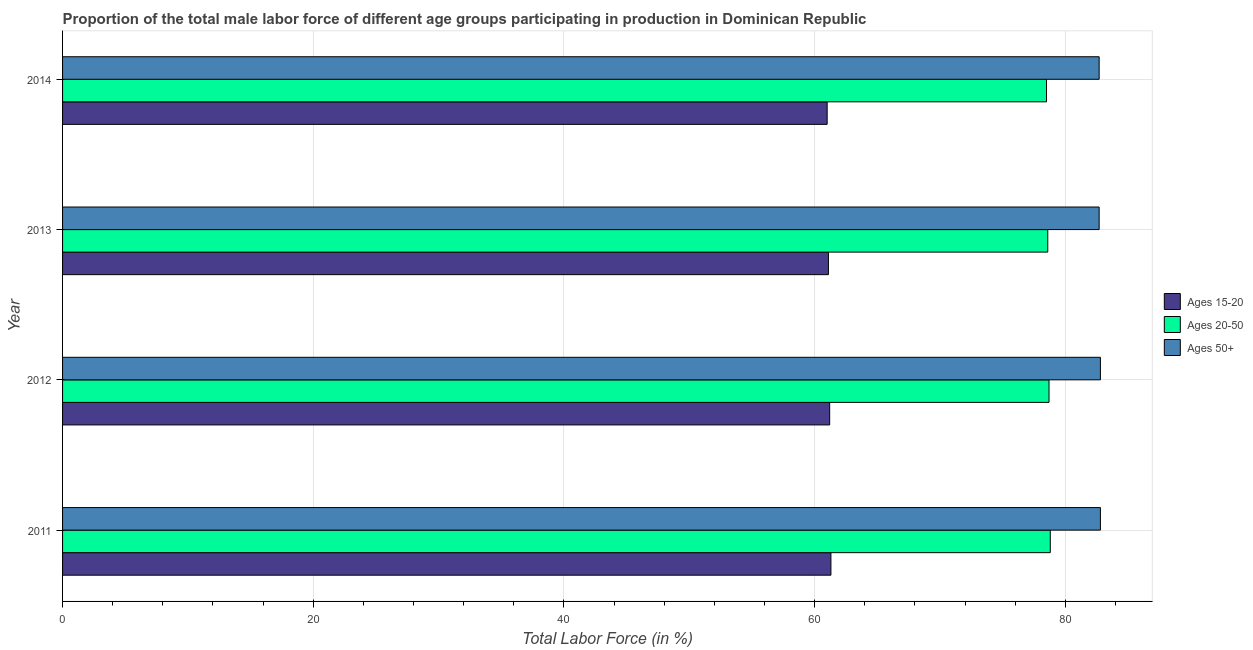How many different coloured bars are there?
Give a very brief answer. 3. What is the label of the 2nd group of bars from the top?
Your response must be concise. 2013. What is the percentage of male labor force within the age group 20-50 in 2011?
Your answer should be very brief. 78.8. Across all years, what is the maximum percentage of male labor force within the age group 15-20?
Provide a succinct answer. 61.3. Across all years, what is the minimum percentage of male labor force within the age group 20-50?
Your answer should be very brief. 78.5. In which year was the percentage of male labor force within the age group 15-20 maximum?
Keep it short and to the point. 2011. In which year was the percentage of male labor force within the age group 20-50 minimum?
Provide a short and direct response. 2014. What is the total percentage of male labor force within the age group 15-20 in the graph?
Offer a terse response. 244.6. What is the difference between the percentage of male labor force within the age group 15-20 in 2011 and that in 2012?
Offer a terse response. 0.1. What is the difference between the percentage of male labor force above age 50 in 2013 and the percentage of male labor force within the age group 15-20 in 2011?
Keep it short and to the point. 21.4. What is the average percentage of male labor force within the age group 15-20 per year?
Provide a succinct answer. 61.15. What is the ratio of the percentage of male labor force within the age group 15-20 in 2013 to that in 2014?
Keep it short and to the point. 1. Is the percentage of male labor force above age 50 in 2012 less than that in 2013?
Provide a succinct answer. No. Is the difference between the percentage of male labor force within the age group 15-20 in 2013 and 2014 greater than the difference between the percentage of male labor force above age 50 in 2013 and 2014?
Keep it short and to the point. Yes. What is the difference between the highest and the lowest percentage of male labor force within the age group 15-20?
Offer a very short reply. 0.3. What does the 2nd bar from the top in 2012 represents?
Your answer should be very brief. Ages 20-50. What does the 1st bar from the bottom in 2014 represents?
Offer a very short reply. Ages 15-20. Are all the bars in the graph horizontal?
Make the answer very short. Yes. How many years are there in the graph?
Your answer should be compact. 4. Does the graph contain any zero values?
Give a very brief answer. No. Where does the legend appear in the graph?
Ensure brevity in your answer.  Center right. How many legend labels are there?
Offer a very short reply. 3. How are the legend labels stacked?
Provide a succinct answer. Vertical. What is the title of the graph?
Offer a very short reply. Proportion of the total male labor force of different age groups participating in production in Dominican Republic. What is the label or title of the X-axis?
Provide a short and direct response. Total Labor Force (in %). What is the label or title of the Y-axis?
Provide a short and direct response. Year. What is the Total Labor Force (in %) of Ages 15-20 in 2011?
Your answer should be compact. 61.3. What is the Total Labor Force (in %) in Ages 20-50 in 2011?
Your response must be concise. 78.8. What is the Total Labor Force (in %) of Ages 50+ in 2011?
Give a very brief answer. 82.8. What is the Total Labor Force (in %) of Ages 15-20 in 2012?
Offer a terse response. 61.2. What is the Total Labor Force (in %) of Ages 20-50 in 2012?
Keep it short and to the point. 78.7. What is the Total Labor Force (in %) in Ages 50+ in 2012?
Provide a short and direct response. 82.8. What is the Total Labor Force (in %) in Ages 15-20 in 2013?
Keep it short and to the point. 61.1. What is the Total Labor Force (in %) of Ages 20-50 in 2013?
Make the answer very short. 78.6. What is the Total Labor Force (in %) of Ages 50+ in 2013?
Provide a succinct answer. 82.7. What is the Total Labor Force (in %) in Ages 15-20 in 2014?
Your answer should be very brief. 61. What is the Total Labor Force (in %) in Ages 20-50 in 2014?
Provide a succinct answer. 78.5. What is the Total Labor Force (in %) of Ages 50+ in 2014?
Your response must be concise. 82.7. Across all years, what is the maximum Total Labor Force (in %) of Ages 15-20?
Your answer should be compact. 61.3. Across all years, what is the maximum Total Labor Force (in %) of Ages 20-50?
Give a very brief answer. 78.8. Across all years, what is the maximum Total Labor Force (in %) of Ages 50+?
Keep it short and to the point. 82.8. Across all years, what is the minimum Total Labor Force (in %) in Ages 20-50?
Your answer should be very brief. 78.5. Across all years, what is the minimum Total Labor Force (in %) in Ages 50+?
Make the answer very short. 82.7. What is the total Total Labor Force (in %) in Ages 15-20 in the graph?
Provide a short and direct response. 244.6. What is the total Total Labor Force (in %) of Ages 20-50 in the graph?
Make the answer very short. 314.6. What is the total Total Labor Force (in %) of Ages 50+ in the graph?
Offer a very short reply. 331. What is the difference between the Total Labor Force (in %) in Ages 20-50 in 2011 and that in 2012?
Your response must be concise. 0.1. What is the difference between the Total Labor Force (in %) in Ages 50+ in 2011 and that in 2012?
Your answer should be very brief. 0. What is the difference between the Total Labor Force (in %) of Ages 15-20 in 2011 and that in 2013?
Provide a short and direct response. 0.2. What is the difference between the Total Labor Force (in %) in Ages 20-50 in 2011 and that in 2013?
Ensure brevity in your answer.  0.2. What is the difference between the Total Labor Force (in %) of Ages 20-50 in 2011 and that in 2014?
Give a very brief answer. 0.3. What is the difference between the Total Labor Force (in %) in Ages 50+ in 2011 and that in 2014?
Ensure brevity in your answer.  0.1. What is the difference between the Total Labor Force (in %) in Ages 15-20 in 2012 and that in 2013?
Give a very brief answer. 0.1. What is the difference between the Total Labor Force (in %) of Ages 20-50 in 2012 and that in 2013?
Keep it short and to the point. 0.1. What is the difference between the Total Labor Force (in %) of Ages 50+ in 2012 and that in 2014?
Provide a succinct answer. 0.1. What is the difference between the Total Labor Force (in %) in Ages 20-50 in 2013 and that in 2014?
Offer a very short reply. 0.1. What is the difference between the Total Labor Force (in %) of Ages 15-20 in 2011 and the Total Labor Force (in %) of Ages 20-50 in 2012?
Offer a terse response. -17.4. What is the difference between the Total Labor Force (in %) of Ages 15-20 in 2011 and the Total Labor Force (in %) of Ages 50+ in 2012?
Provide a short and direct response. -21.5. What is the difference between the Total Labor Force (in %) in Ages 20-50 in 2011 and the Total Labor Force (in %) in Ages 50+ in 2012?
Ensure brevity in your answer.  -4. What is the difference between the Total Labor Force (in %) in Ages 15-20 in 2011 and the Total Labor Force (in %) in Ages 20-50 in 2013?
Keep it short and to the point. -17.3. What is the difference between the Total Labor Force (in %) of Ages 15-20 in 2011 and the Total Labor Force (in %) of Ages 50+ in 2013?
Your answer should be very brief. -21.4. What is the difference between the Total Labor Force (in %) of Ages 20-50 in 2011 and the Total Labor Force (in %) of Ages 50+ in 2013?
Your answer should be very brief. -3.9. What is the difference between the Total Labor Force (in %) of Ages 15-20 in 2011 and the Total Labor Force (in %) of Ages 20-50 in 2014?
Give a very brief answer. -17.2. What is the difference between the Total Labor Force (in %) of Ages 15-20 in 2011 and the Total Labor Force (in %) of Ages 50+ in 2014?
Offer a very short reply. -21.4. What is the difference between the Total Labor Force (in %) in Ages 20-50 in 2011 and the Total Labor Force (in %) in Ages 50+ in 2014?
Your response must be concise. -3.9. What is the difference between the Total Labor Force (in %) in Ages 15-20 in 2012 and the Total Labor Force (in %) in Ages 20-50 in 2013?
Make the answer very short. -17.4. What is the difference between the Total Labor Force (in %) in Ages 15-20 in 2012 and the Total Labor Force (in %) in Ages 50+ in 2013?
Provide a succinct answer. -21.5. What is the difference between the Total Labor Force (in %) of Ages 20-50 in 2012 and the Total Labor Force (in %) of Ages 50+ in 2013?
Provide a succinct answer. -4. What is the difference between the Total Labor Force (in %) in Ages 15-20 in 2012 and the Total Labor Force (in %) in Ages 20-50 in 2014?
Your answer should be very brief. -17.3. What is the difference between the Total Labor Force (in %) in Ages 15-20 in 2012 and the Total Labor Force (in %) in Ages 50+ in 2014?
Offer a very short reply. -21.5. What is the difference between the Total Labor Force (in %) in Ages 15-20 in 2013 and the Total Labor Force (in %) in Ages 20-50 in 2014?
Your answer should be compact. -17.4. What is the difference between the Total Labor Force (in %) in Ages 15-20 in 2013 and the Total Labor Force (in %) in Ages 50+ in 2014?
Provide a short and direct response. -21.6. What is the difference between the Total Labor Force (in %) of Ages 20-50 in 2013 and the Total Labor Force (in %) of Ages 50+ in 2014?
Your answer should be very brief. -4.1. What is the average Total Labor Force (in %) in Ages 15-20 per year?
Offer a terse response. 61.15. What is the average Total Labor Force (in %) in Ages 20-50 per year?
Provide a short and direct response. 78.65. What is the average Total Labor Force (in %) of Ages 50+ per year?
Offer a very short reply. 82.75. In the year 2011, what is the difference between the Total Labor Force (in %) of Ages 15-20 and Total Labor Force (in %) of Ages 20-50?
Your response must be concise. -17.5. In the year 2011, what is the difference between the Total Labor Force (in %) in Ages 15-20 and Total Labor Force (in %) in Ages 50+?
Ensure brevity in your answer.  -21.5. In the year 2012, what is the difference between the Total Labor Force (in %) in Ages 15-20 and Total Labor Force (in %) in Ages 20-50?
Offer a very short reply. -17.5. In the year 2012, what is the difference between the Total Labor Force (in %) in Ages 15-20 and Total Labor Force (in %) in Ages 50+?
Keep it short and to the point. -21.6. In the year 2012, what is the difference between the Total Labor Force (in %) of Ages 20-50 and Total Labor Force (in %) of Ages 50+?
Give a very brief answer. -4.1. In the year 2013, what is the difference between the Total Labor Force (in %) in Ages 15-20 and Total Labor Force (in %) in Ages 20-50?
Ensure brevity in your answer.  -17.5. In the year 2013, what is the difference between the Total Labor Force (in %) of Ages 15-20 and Total Labor Force (in %) of Ages 50+?
Offer a very short reply. -21.6. In the year 2013, what is the difference between the Total Labor Force (in %) of Ages 20-50 and Total Labor Force (in %) of Ages 50+?
Offer a terse response. -4.1. In the year 2014, what is the difference between the Total Labor Force (in %) in Ages 15-20 and Total Labor Force (in %) in Ages 20-50?
Keep it short and to the point. -17.5. In the year 2014, what is the difference between the Total Labor Force (in %) of Ages 15-20 and Total Labor Force (in %) of Ages 50+?
Your answer should be compact. -21.7. What is the ratio of the Total Labor Force (in %) of Ages 15-20 in 2011 to that in 2012?
Keep it short and to the point. 1. What is the ratio of the Total Labor Force (in %) of Ages 20-50 in 2011 to that in 2012?
Your answer should be compact. 1. What is the ratio of the Total Labor Force (in %) of Ages 15-20 in 2011 to that in 2013?
Offer a terse response. 1. What is the ratio of the Total Labor Force (in %) of Ages 20-50 in 2011 to that in 2013?
Give a very brief answer. 1. What is the ratio of the Total Labor Force (in %) in Ages 50+ in 2011 to that in 2013?
Give a very brief answer. 1. What is the ratio of the Total Labor Force (in %) in Ages 50+ in 2011 to that in 2014?
Keep it short and to the point. 1. What is the ratio of the Total Labor Force (in %) in Ages 20-50 in 2012 to that in 2013?
Offer a very short reply. 1. What is the ratio of the Total Labor Force (in %) of Ages 15-20 in 2012 to that in 2014?
Keep it short and to the point. 1. What is the ratio of the Total Labor Force (in %) in Ages 50+ in 2012 to that in 2014?
Keep it short and to the point. 1. What is the ratio of the Total Labor Force (in %) in Ages 15-20 in 2013 to that in 2014?
Offer a terse response. 1. What is the difference between the highest and the second highest Total Labor Force (in %) of Ages 15-20?
Give a very brief answer. 0.1. What is the difference between the highest and the lowest Total Labor Force (in %) of Ages 15-20?
Keep it short and to the point. 0.3. What is the difference between the highest and the lowest Total Labor Force (in %) in Ages 20-50?
Your answer should be compact. 0.3. What is the difference between the highest and the lowest Total Labor Force (in %) of Ages 50+?
Your answer should be compact. 0.1. 